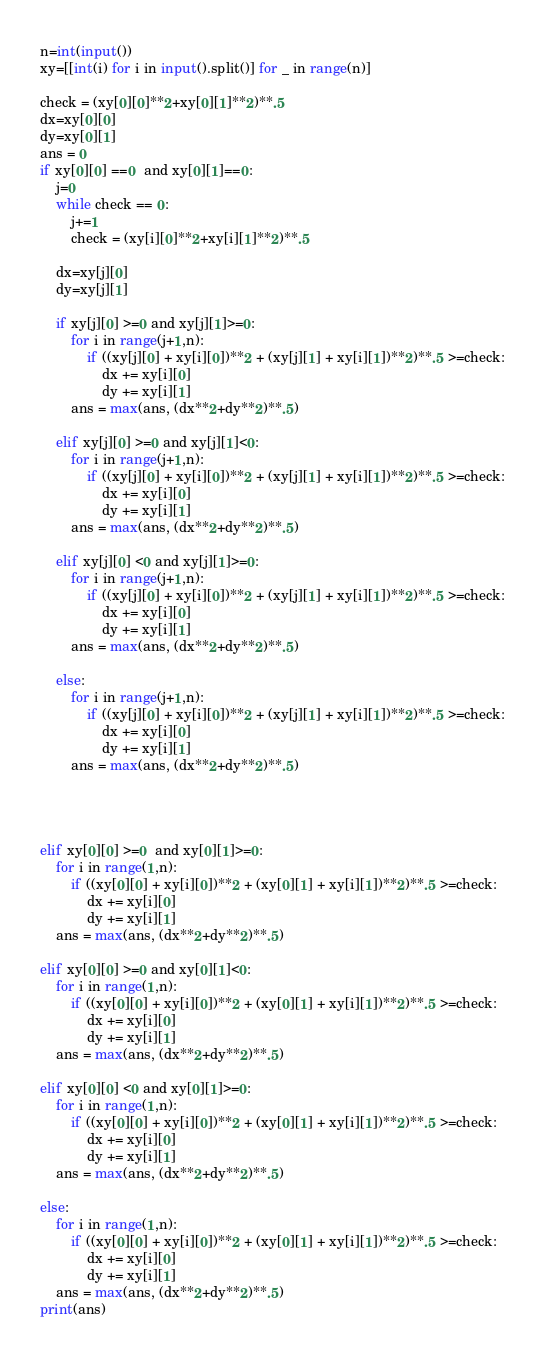Convert code to text. <code><loc_0><loc_0><loc_500><loc_500><_Python_>n=int(input())
xy=[[int(i) for i in input().split()] for _ in range(n)]

check = (xy[0][0]**2+xy[0][1]**2)**.5
dx=xy[0][0]
dy=xy[0][1]
ans = 0
if xy[0][0] ==0  and xy[0][1]==0:
    j=0
    while check == 0:
        j+=1
        check = (xy[i][0]**2+xy[i][1]**2)**.5
    
    dx=xy[j][0]
    dy=xy[j][1]
        
    if xy[j][0] >=0 and xy[j][1]>=0:
        for i in range(j+1,n):
            if ((xy[j][0] + xy[i][0])**2 + (xy[j][1] + xy[i][1])**2)**.5 >=check:
                dx += xy[i][0]
                dy += xy[i][1]
        ans = max(ans, (dx**2+dy**2)**.5)
    
    elif xy[j][0] >=0 and xy[j][1]<0:
        for i in range(j+1,n):
            if ((xy[j][0] + xy[i][0])**2 + (xy[j][1] + xy[i][1])**2)**.5 >=check:
                dx += xy[i][0]
                dy += xy[i][1]
        ans = max(ans, (dx**2+dy**2)**.5)
    
    elif xy[j][0] <0 and xy[j][1]>=0:
        for i in range(j+1,n):
            if ((xy[j][0] + xy[i][0])**2 + (xy[j][1] + xy[i][1])**2)**.5 >=check:
                dx += xy[i][0]
                dy += xy[i][1]
        ans = max(ans, (dx**2+dy**2)**.5)
    
    else:
        for i in range(j+1,n):
            if ((xy[j][0] + xy[i][0])**2 + (xy[j][1] + xy[i][1])**2)**.5 >=check:
                dx += xy[i][0]
                dy += xy[i][1]
        ans = max(ans, (dx**2+dy**2)**.5)
    
    
    
    
elif xy[0][0] >=0  and xy[0][1]>=0:
    for i in range(1,n):
        if ((xy[0][0] + xy[i][0])**2 + (xy[0][1] + xy[i][1])**2)**.5 >=check:
            dx += xy[i][0]
            dy += xy[i][1]
    ans = max(ans, (dx**2+dy**2)**.5)
    
elif xy[0][0] >=0 and xy[0][1]<0:
    for i in range(1,n):
        if ((xy[0][0] + xy[i][0])**2 + (xy[0][1] + xy[i][1])**2)**.5 >=check:
            dx += xy[i][0]
            dy += xy[i][1]
    ans = max(ans, (dx**2+dy**2)**.5)
        
elif xy[0][0] <0 and xy[0][1]>=0:
    for i in range(1,n):
        if ((xy[0][0] + xy[i][0])**2 + (xy[0][1] + xy[i][1])**2)**.5 >=check:
            dx += xy[i][0]
            dy += xy[i][1]
    ans = max(ans, (dx**2+dy**2)**.5)
        
else:
    for i in range(1,n):
        if ((xy[0][0] + xy[i][0])**2 + (xy[0][1] + xy[i][1])**2)**.5 >=check:
            dx += xy[i][0]
            dy += xy[i][1]
    ans = max(ans, (dx**2+dy**2)**.5)
print(ans)</code> 